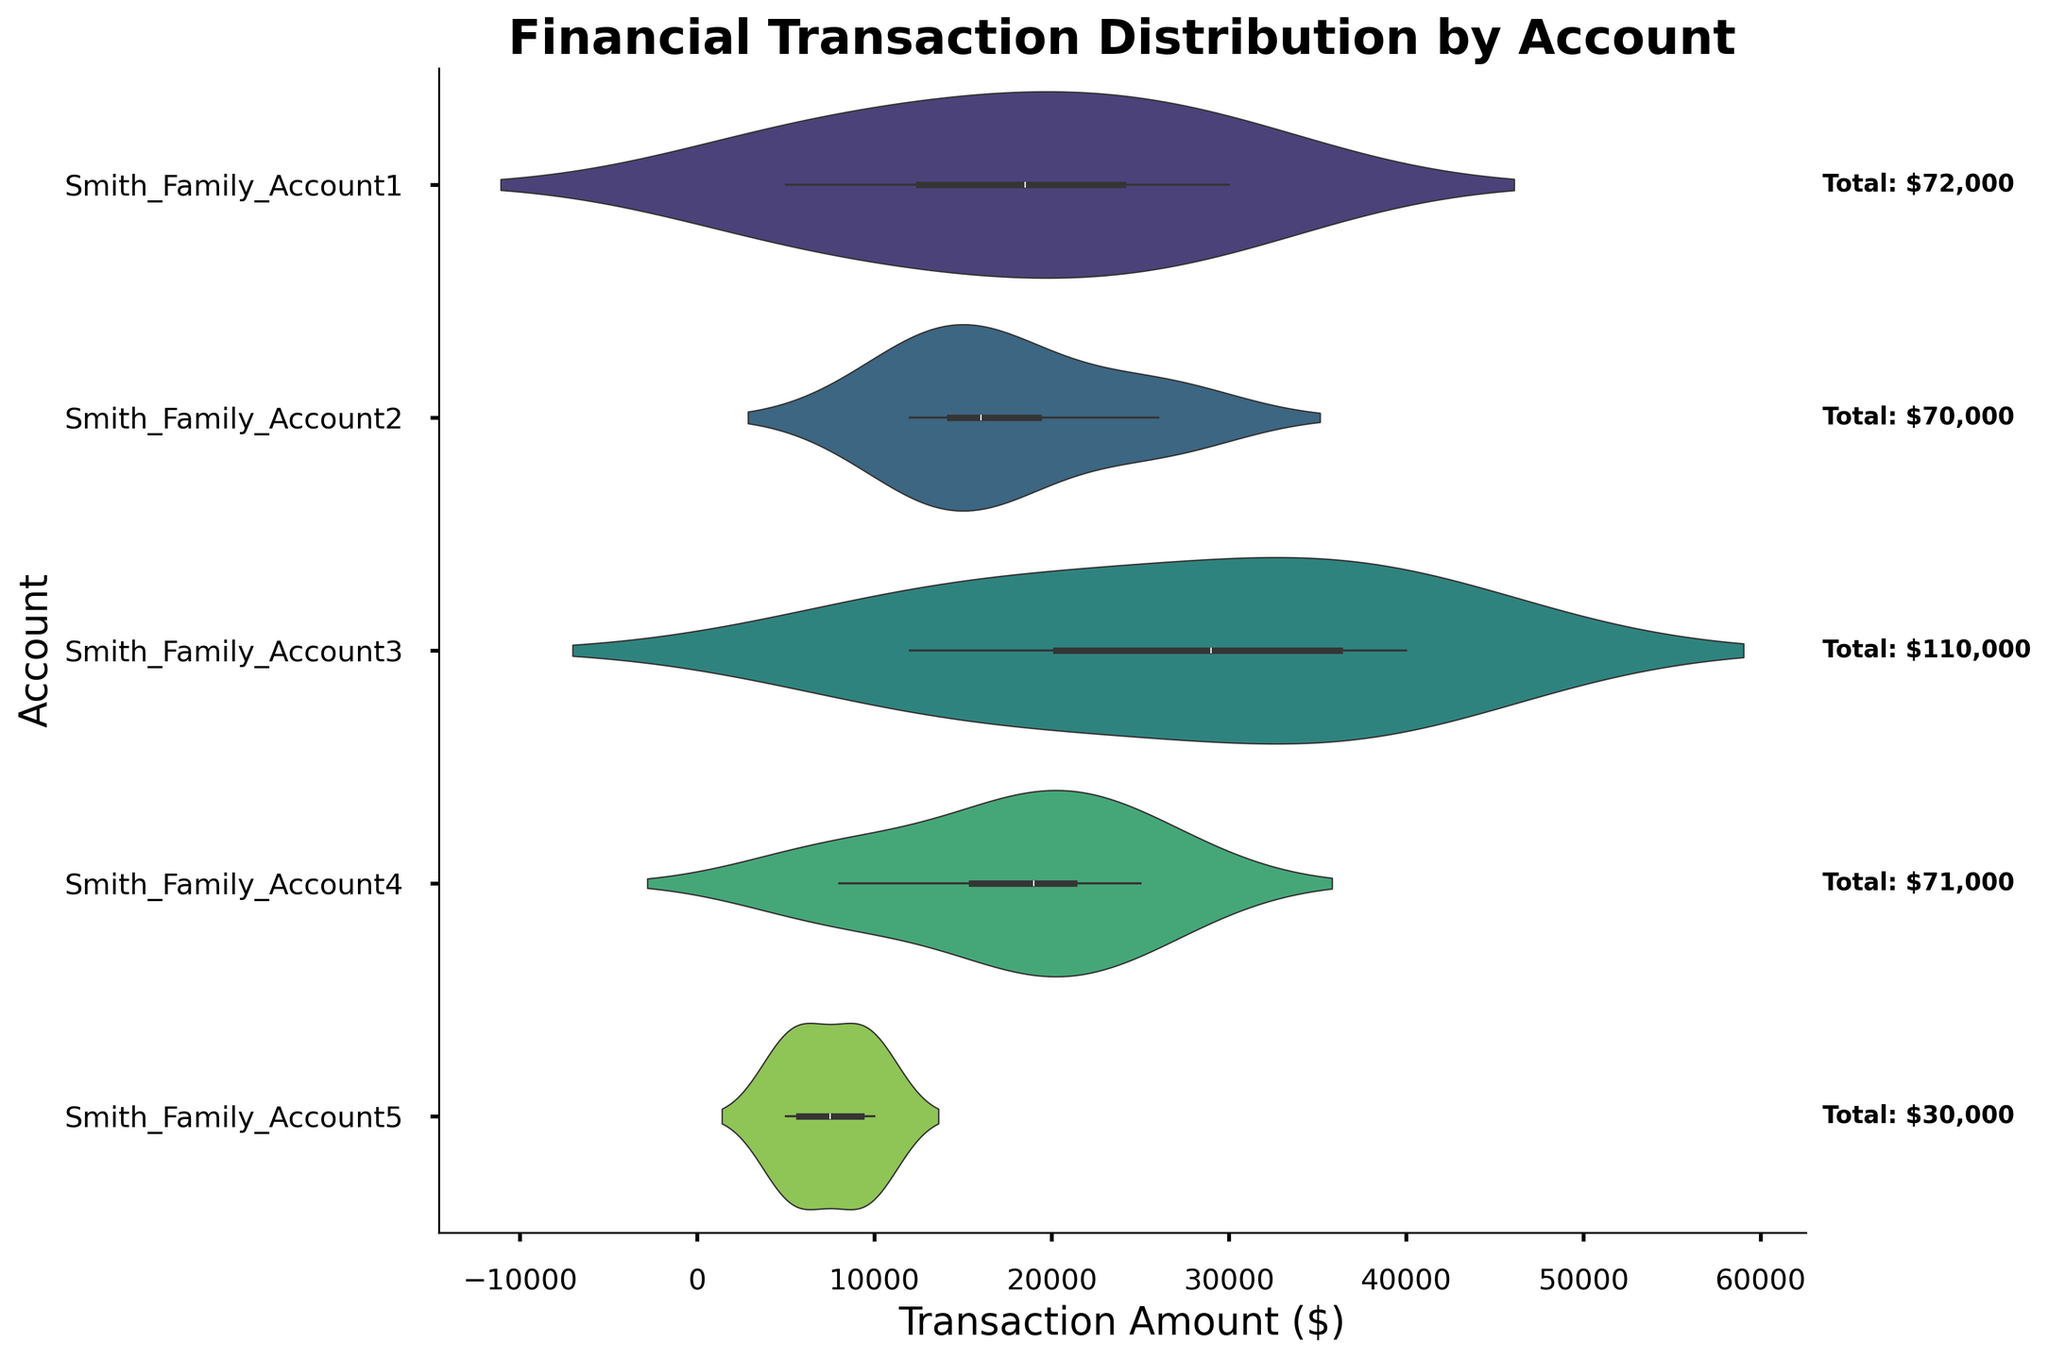what is the total transaction amount for Smith_Family_Account1? Locate the text annotation next to Smith_Family_Account1 in the figure. The annotation shows "Total: $72,000" for Smith_Family_Account1.
Answer: $72,000 which account has the highest total transaction amount? Compare the total amounts annotated next to each account. Smith_Family_Account3 has the highest annotation with "Total: $110,000".
Answer: Smith_Family_Account3 which account has the lowest total transaction amount? Compare the total amounts annotated next to each account. Smith_Family_Account5 has the lowest annotation with "Total: $30,000".
Answer: Smith_Family_Account5 what is the range of transaction amounts for Smith_Family_Account2? Observe the spread of the violin plot for Smith_Family_Account2. The visual data extends from around $5,000 to $30,000.
Answer: $5,000 to $30,000 which account has the widest range of transaction amounts? Compare the spreads of the violin plots for all accounts. Smith_Family_Account3 has the widest range from around $8,000 to $40,000.
Answer: Smith_Family_Account3 what is the most common transaction amount for Smith_Family_Account4? Observe the density and the inner box in the violin plot for Smith_Family_Account4. The highest density appears around $20,000.
Answer: $20,000 how many accounts have transactions above $25,000? Count the accounts whose violin plots extend above the $25,000 mark. Smith_Family_Account1, Smith_Family_Account2, Smith_Family_Account3, and Smith_Family_Account4 meet this criterion.
Answer: 4 which account shows the most symmetrical distribution in transaction amounts? Observe the shape of the violin plots. Smith_Family_Account4 has a relatively symmetrical shape.
Answer: Smith_Family_Account4 